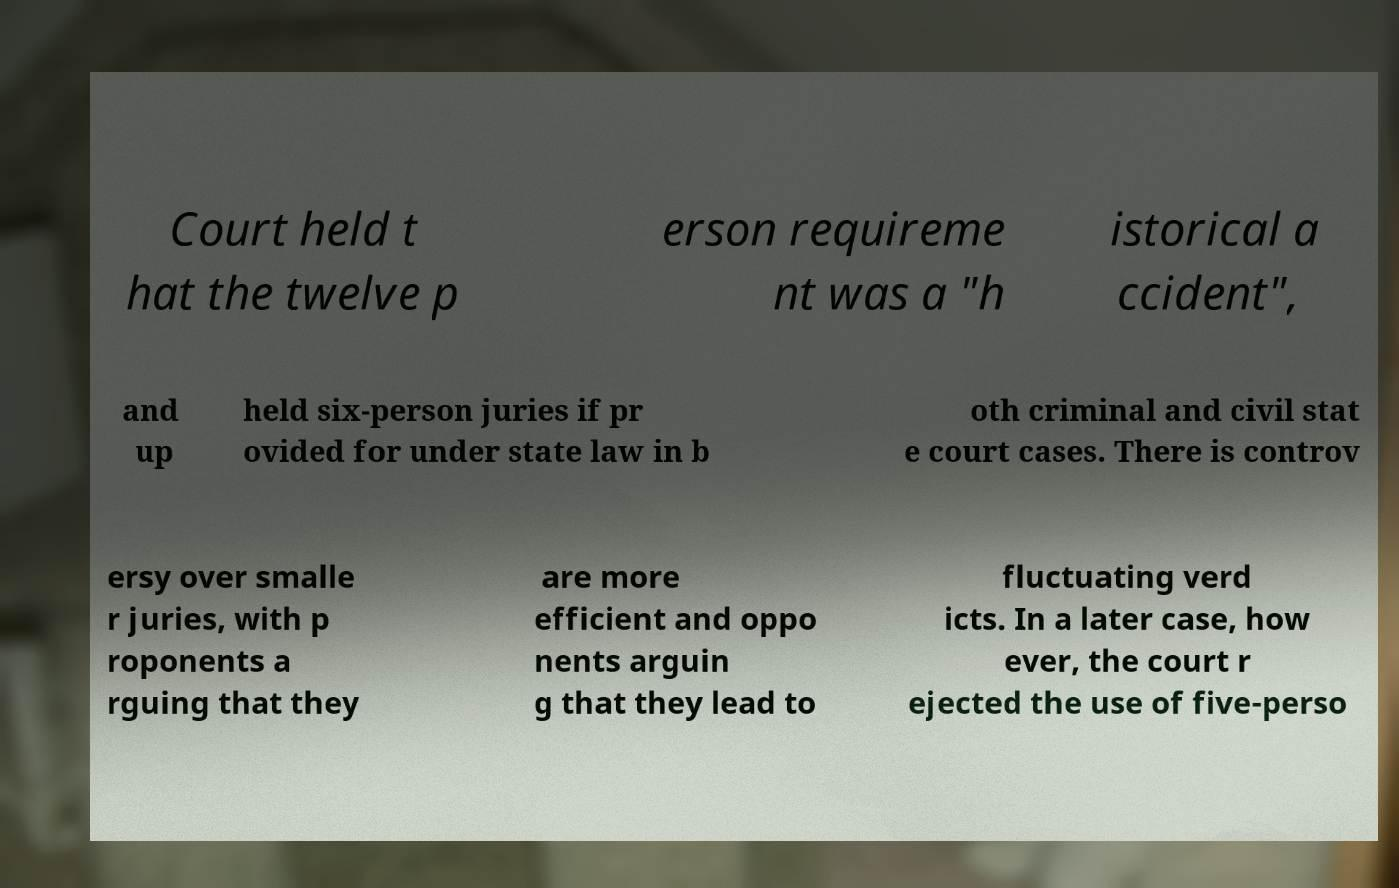Could you assist in decoding the text presented in this image and type it out clearly? Court held t hat the twelve p erson requireme nt was a "h istorical a ccident", and up held six-person juries if pr ovided for under state law in b oth criminal and civil stat e court cases. There is controv ersy over smalle r juries, with p roponents a rguing that they are more efficient and oppo nents arguin g that they lead to fluctuating verd icts. In a later case, how ever, the court r ejected the use of five-perso 